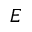<formula> <loc_0><loc_0><loc_500><loc_500>E</formula> 